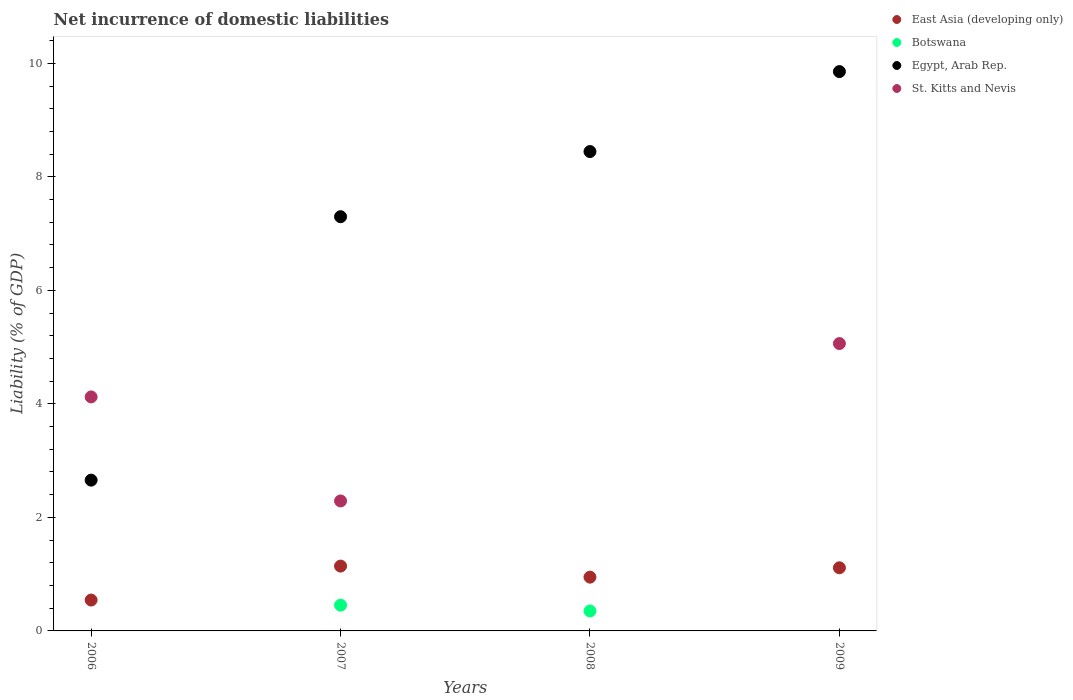How many different coloured dotlines are there?
Keep it short and to the point. 4. Is the number of dotlines equal to the number of legend labels?
Provide a succinct answer. No. What is the net incurrence of domestic liabilities in East Asia (developing only) in 2006?
Your answer should be very brief. 0.54. Across all years, what is the maximum net incurrence of domestic liabilities in Botswana?
Make the answer very short. 0.45. What is the total net incurrence of domestic liabilities in East Asia (developing only) in the graph?
Ensure brevity in your answer.  3.75. What is the difference between the net incurrence of domestic liabilities in East Asia (developing only) in 2008 and that in 2009?
Your answer should be compact. -0.16. What is the difference between the net incurrence of domestic liabilities in East Asia (developing only) in 2008 and the net incurrence of domestic liabilities in Botswana in 2007?
Your response must be concise. 0.49. What is the average net incurrence of domestic liabilities in Botswana per year?
Keep it short and to the point. 0.2. In the year 2008, what is the difference between the net incurrence of domestic liabilities in Botswana and net incurrence of domestic liabilities in Egypt, Arab Rep.?
Give a very brief answer. -8.09. What is the ratio of the net incurrence of domestic liabilities in East Asia (developing only) in 2006 to that in 2008?
Keep it short and to the point. 0.57. Is the net incurrence of domestic liabilities in Egypt, Arab Rep. in 2008 less than that in 2009?
Make the answer very short. Yes. What is the difference between the highest and the second highest net incurrence of domestic liabilities in St. Kitts and Nevis?
Ensure brevity in your answer.  0.94. What is the difference between the highest and the lowest net incurrence of domestic liabilities in East Asia (developing only)?
Offer a terse response. 0.6. Is it the case that in every year, the sum of the net incurrence of domestic liabilities in East Asia (developing only) and net incurrence of domestic liabilities in Egypt, Arab Rep.  is greater than the net incurrence of domestic liabilities in St. Kitts and Nevis?
Keep it short and to the point. No. Is the net incurrence of domestic liabilities in East Asia (developing only) strictly greater than the net incurrence of domestic liabilities in Botswana over the years?
Ensure brevity in your answer.  Yes. How many years are there in the graph?
Provide a short and direct response. 4. What is the difference between two consecutive major ticks on the Y-axis?
Your answer should be compact. 2. Does the graph contain any zero values?
Your response must be concise. Yes. How many legend labels are there?
Keep it short and to the point. 4. How are the legend labels stacked?
Ensure brevity in your answer.  Vertical. What is the title of the graph?
Give a very brief answer. Net incurrence of domestic liabilities. What is the label or title of the Y-axis?
Your answer should be very brief. Liability (% of GDP). What is the Liability (% of GDP) in East Asia (developing only) in 2006?
Offer a very short reply. 0.54. What is the Liability (% of GDP) in Egypt, Arab Rep. in 2006?
Provide a short and direct response. 2.66. What is the Liability (% of GDP) of St. Kitts and Nevis in 2006?
Offer a terse response. 4.12. What is the Liability (% of GDP) in East Asia (developing only) in 2007?
Your answer should be very brief. 1.14. What is the Liability (% of GDP) in Botswana in 2007?
Ensure brevity in your answer.  0.45. What is the Liability (% of GDP) of Egypt, Arab Rep. in 2007?
Your response must be concise. 7.3. What is the Liability (% of GDP) of St. Kitts and Nevis in 2007?
Your answer should be very brief. 2.29. What is the Liability (% of GDP) in East Asia (developing only) in 2008?
Ensure brevity in your answer.  0.95. What is the Liability (% of GDP) of Botswana in 2008?
Offer a terse response. 0.35. What is the Liability (% of GDP) in Egypt, Arab Rep. in 2008?
Your answer should be very brief. 8.45. What is the Liability (% of GDP) of East Asia (developing only) in 2009?
Make the answer very short. 1.11. What is the Liability (% of GDP) in Egypt, Arab Rep. in 2009?
Give a very brief answer. 9.85. What is the Liability (% of GDP) in St. Kitts and Nevis in 2009?
Provide a succinct answer. 5.06. Across all years, what is the maximum Liability (% of GDP) of East Asia (developing only)?
Your response must be concise. 1.14. Across all years, what is the maximum Liability (% of GDP) in Botswana?
Your answer should be very brief. 0.45. Across all years, what is the maximum Liability (% of GDP) in Egypt, Arab Rep.?
Offer a terse response. 9.85. Across all years, what is the maximum Liability (% of GDP) of St. Kitts and Nevis?
Keep it short and to the point. 5.06. Across all years, what is the minimum Liability (% of GDP) of East Asia (developing only)?
Make the answer very short. 0.54. Across all years, what is the minimum Liability (% of GDP) in Egypt, Arab Rep.?
Your answer should be compact. 2.66. What is the total Liability (% of GDP) of East Asia (developing only) in the graph?
Your answer should be compact. 3.75. What is the total Liability (% of GDP) in Botswana in the graph?
Make the answer very short. 0.81. What is the total Liability (% of GDP) of Egypt, Arab Rep. in the graph?
Make the answer very short. 28.25. What is the total Liability (% of GDP) in St. Kitts and Nevis in the graph?
Your response must be concise. 11.48. What is the difference between the Liability (% of GDP) in East Asia (developing only) in 2006 and that in 2007?
Ensure brevity in your answer.  -0.6. What is the difference between the Liability (% of GDP) of Egypt, Arab Rep. in 2006 and that in 2007?
Provide a short and direct response. -4.64. What is the difference between the Liability (% of GDP) in St. Kitts and Nevis in 2006 and that in 2007?
Ensure brevity in your answer.  1.83. What is the difference between the Liability (% of GDP) in East Asia (developing only) in 2006 and that in 2008?
Make the answer very short. -0.4. What is the difference between the Liability (% of GDP) of Egypt, Arab Rep. in 2006 and that in 2008?
Offer a very short reply. -5.79. What is the difference between the Liability (% of GDP) of East Asia (developing only) in 2006 and that in 2009?
Provide a short and direct response. -0.57. What is the difference between the Liability (% of GDP) of Egypt, Arab Rep. in 2006 and that in 2009?
Give a very brief answer. -7.2. What is the difference between the Liability (% of GDP) of St. Kitts and Nevis in 2006 and that in 2009?
Offer a very short reply. -0.94. What is the difference between the Liability (% of GDP) of East Asia (developing only) in 2007 and that in 2008?
Your answer should be very brief. 0.19. What is the difference between the Liability (% of GDP) in Botswana in 2007 and that in 2008?
Give a very brief answer. 0.1. What is the difference between the Liability (% of GDP) in Egypt, Arab Rep. in 2007 and that in 2008?
Provide a short and direct response. -1.15. What is the difference between the Liability (% of GDP) of East Asia (developing only) in 2007 and that in 2009?
Keep it short and to the point. 0.03. What is the difference between the Liability (% of GDP) of Egypt, Arab Rep. in 2007 and that in 2009?
Your answer should be very brief. -2.56. What is the difference between the Liability (% of GDP) in St. Kitts and Nevis in 2007 and that in 2009?
Offer a terse response. -2.77. What is the difference between the Liability (% of GDP) in East Asia (developing only) in 2008 and that in 2009?
Offer a very short reply. -0.16. What is the difference between the Liability (% of GDP) in Egypt, Arab Rep. in 2008 and that in 2009?
Offer a terse response. -1.41. What is the difference between the Liability (% of GDP) of East Asia (developing only) in 2006 and the Liability (% of GDP) of Botswana in 2007?
Provide a short and direct response. 0.09. What is the difference between the Liability (% of GDP) of East Asia (developing only) in 2006 and the Liability (% of GDP) of Egypt, Arab Rep. in 2007?
Make the answer very short. -6.75. What is the difference between the Liability (% of GDP) of East Asia (developing only) in 2006 and the Liability (% of GDP) of St. Kitts and Nevis in 2007?
Your answer should be compact. -1.75. What is the difference between the Liability (% of GDP) in Egypt, Arab Rep. in 2006 and the Liability (% of GDP) in St. Kitts and Nevis in 2007?
Make the answer very short. 0.37. What is the difference between the Liability (% of GDP) in East Asia (developing only) in 2006 and the Liability (% of GDP) in Botswana in 2008?
Keep it short and to the point. 0.19. What is the difference between the Liability (% of GDP) of East Asia (developing only) in 2006 and the Liability (% of GDP) of Egypt, Arab Rep. in 2008?
Your answer should be very brief. -7.9. What is the difference between the Liability (% of GDP) of East Asia (developing only) in 2006 and the Liability (% of GDP) of Egypt, Arab Rep. in 2009?
Offer a terse response. -9.31. What is the difference between the Liability (% of GDP) in East Asia (developing only) in 2006 and the Liability (% of GDP) in St. Kitts and Nevis in 2009?
Your answer should be compact. -4.52. What is the difference between the Liability (% of GDP) in Egypt, Arab Rep. in 2006 and the Liability (% of GDP) in St. Kitts and Nevis in 2009?
Your answer should be very brief. -2.41. What is the difference between the Liability (% of GDP) in East Asia (developing only) in 2007 and the Liability (% of GDP) in Botswana in 2008?
Make the answer very short. 0.79. What is the difference between the Liability (% of GDP) in East Asia (developing only) in 2007 and the Liability (% of GDP) in Egypt, Arab Rep. in 2008?
Your answer should be very brief. -7.3. What is the difference between the Liability (% of GDP) of Botswana in 2007 and the Liability (% of GDP) of Egypt, Arab Rep. in 2008?
Provide a succinct answer. -7.99. What is the difference between the Liability (% of GDP) in East Asia (developing only) in 2007 and the Liability (% of GDP) in Egypt, Arab Rep. in 2009?
Provide a succinct answer. -8.71. What is the difference between the Liability (% of GDP) in East Asia (developing only) in 2007 and the Liability (% of GDP) in St. Kitts and Nevis in 2009?
Your response must be concise. -3.92. What is the difference between the Liability (% of GDP) in Botswana in 2007 and the Liability (% of GDP) in Egypt, Arab Rep. in 2009?
Your answer should be very brief. -9.4. What is the difference between the Liability (% of GDP) of Botswana in 2007 and the Liability (% of GDP) of St. Kitts and Nevis in 2009?
Offer a terse response. -4.61. What is the difference between the Liability (% of GDP) of Egypt, Arab Rep. in 2007 and the Liability (% of GDP) of St. Kitts and Nevis in 2009?
Give a very brief answer. 2.23. What is the difference between the Liability (% of GDP) of East Asia (developing only) in 2008 and the Liability (% of GDP) of Egypt, Arab Rep. in 2009?
Offer a very short reply. -8.91. What is the difference between the Liability (% of GDP) in East Asia (developing only) in 2008 and the Liability (% of GDP) in St. Kitts and Nevis in 2009?
Make the answer very short. -4.12. What is the difference between the Liability (% of GDP) of Botswana in 2008 and the Liability (% of GDP) of Egypt, Arab Rep. in 2009?
Ensure brevity in your answer.  -9.5. What is the difference between the Liability (% of GDP) of Botswana in 2008 and the Liability (% of GDP) of St. Kitts and Nevis in 2009?
Your answer should be compact. -4.71. What is the difference between the Liability (% of GDP) of Egypt, Arab Rep. in 2008 and the Liability (% of GDP) of St. Kitts and Nevis in 2009?
Give a very brief answer. 3.38. What is the average Liability (% of GDP) of East Asia (developing only) per year?
Your answer should be compact. 0.94. What is the average Liability (% of GDP) of Botswana per year?
Ensure brevity in your answer.  0.2. What is the average Liability (% of GDP) of Egypt, Arab Rep. per year?
Ensure brevity in your answer.  7.06. What is the average Liability (% of GDP) of St. Kitts and Nevis per year?
Keep it short and to the point. 2.87. In the year 2006, what is the difference between the Liability (% of GDP) in East Asia (developing only) and Liability (% of GDP) in Egypt, Arab Rep.?
Offer a very short reply. -2.11. In the year 2006, what is the difference between the Liability (% of GDP) in East Asia (developing only) and Liability (% of GDP) in St. Kitts and Nevis?
Your answer should be very brief. -3.58. In the year 2006, what is the difference between the Liability (% of GDP) of Egypt, Arab Rep. and Liability (% of GDP) of St. Kitts and Nevis?
Provide a short and direct response. -1.47. In the year 2007, what is the difference between the Liability (% of GDP) in East Asia (developing only) and Liability (% of GDP) in Botswana?
Keep it short and to the point. 0.69. In the year 2007, what is the difference between the Liability (% of GDP) of East Asia (developing only) and Liability (% of GDP) of Egypt, Arab Rep.?
Make the answer very short. -6.16. In the year 2007, what is the difference between the Liability (% of GDP) in East Asia (developing only) and Liability (% of GDP) in St. Kitts and Nevis?
Your answer should be very brief. -1.15. In the year 2007, what is the difference between the Liability (% of GDP) in Botswana and Liability (% of GDP) in Egypt, Arab Rep.?
Your answer should be very brief. -6.84. In the year 2007, what is the difference between the Liability (% of GDP) of Botswana and Liability (% of GDP) of St. Kitts and Nevis?
Provide a short and direct response. -1.84. In the year 2007, what is the difference between the Liability (% of GDP) in Egypt, Arab Rep. and Liability (% of GDP) in St. Kitts and Nevis?
Keep it short and to the point. 5.01. In the year 2008, what is the difference between the Liability (% of GDP) of East Asia (developing only) and Liability (% of GDP) of Botswana?
Provide a short and direct response. 0.6. In the year 2008, what is the difference between the Liability (% of GDP) of East Asia (developing only) and Liability (% of GDP) of Egypt, Arab Rep.?
Offer a very short reply. -7.5. In the year 2008, what is the difference between the Liability (% of GDP) in Botswana and Liability (% of GDP) in Egypt, Arab Rep.?
Provide a succinct answer. -8.09. In the year 2009, what is the difference between the Liability (% of GDP) of East Asia (developing only) and Liability (% of GDP) of Egypt, Arab Rep.?
Ensure brevity in your answer.  -8.74. In the year 2009, what is the difference between the Liability (% of GDP) in East Asia (developing only) and Liability (% of GDP) in St. Kitts and Nevis?
Your response must be concise. -3.95. In the year 2009, what is the difference between the Liability (% of GDP) in Egypt, Arab Rep. and Liability (% of GDP) in St. Kitts and Nevis?
Your answer should be very brief. 4.79. What is the ratio of the Liability (% of GDP) of East Asia (developing only) in 2006 to that in 2007?
Ensure brevity in your answer.  0.48. What is the ratio of the Liability (% of GDP) in Egypt, Arab Rep. in 2006 to that in 2007?
Ensure brevity in your answer.  0.36. What is the ratio of the Liability (% of GDP) in St. Kitts and Nevis in 2006 to that in 2007?
Your answer should be very brief. 1.8. What is the ratio of the Liability (% of GDP) in East Asia (developing only) in 2006 to that in 2008?
Provide a short and direct response. 0.57. What is the ratio of the Liability (% of GDP) of Egypt, Arab Rep. in 2006 to that in 2008?
Keep it short and to the point. 0.31. What is the ratio of the Liability (% of GDP) in East Asia (developing only) in 2006 to that in 2009?
Ensure brevity in your answer.  0.49. What is the ratio of the Liability (% of GDP) of Egypt, Arab Rep. in 2006 to that in 2009?
Make the answer very short. 0.27. What is the ratio of the Liability (% of GDP) in St. Kitts and Nevis in 2006 to that in 2009?
Give a very brief answer. 0.81. What is the ratio of the Liability (% of GDP) of East Asia (developing only) in 2007 to that in 2008?
Provide a short and direct response. 1.21. What is the ratio of the Liability (% of GDP) of Botswana in 2007 to that in 2008?
Give a very brief answer. 1.29. What is the ratio of the Liability (% of GDP) of Egypt, Arab Rep. in 2007 to that in 2008?
Give a very brief answer. 0.86. What is the ratio of the Liability (% of GDP) in East Asia (developing only) in 2007 to that in 2009?
Offer a very short reply. 1.03. What is the ratio of the Liability (% of GDP) of Egypt, Arab Rep. in 2007 to that in 2009?
Keep it short and to the point. 0.74. What is the ratio of the Liability (% of GDP) of St. Kitts and Nevis in 2007 to that in 2009?
Give a very brief answer. 0.45. What is the ratio of the Liability (% of GDP) of East Asia (developing only) in 2008 to that in 2009?
Offer a very short reply. 0.85. What is the ratio of the Liability (% of GDP) of Egypt, Arab Rep. in 2008 to that in 2009?
Your answer should be compact. 0.86. What is the difference between the highest and the second highest Liability (% of GDP) of East Asia (developing only)?
Your answer should be compact. 0.03. What is the difference between the highest and the second highest Liability (% of GDP) in Egypt, Arab Rep.?
Provide a succinct answer. 1.41. What is the difference between the highest and the second highest Liability (% of GDP) of St. Kitts and Nevis?
Keep it short and to the point. 0.94. What is the difference between the highest and the lowest Liability (% of GDP) in East Asia (developing only)?
Your answer should be compact. 0.6. What is the difference between the highest and the lowest Liability (% of GDP) of Botswana?
Your answer should be compact. 0.45. What is the difference between the highest and the lowest Liability (% of GDP) in Egypt, Arab Rep.?
Offer a terse response. 7.2. What is the difference between the highest and the lowest Liability (% of GDP) of St. Kitts and Nevis?
Your answer should be compact. 5.06. 